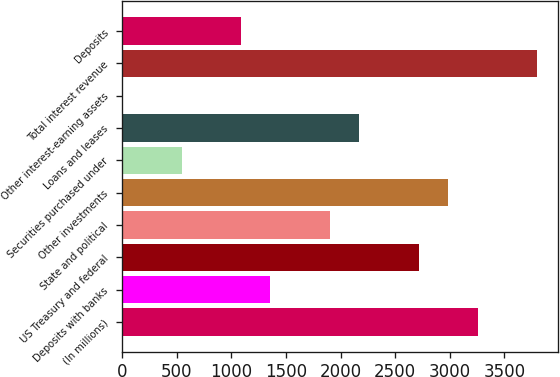Convert chart to OTSL. <chart><loc_0><loc_0><loc_500><loc_500><bar_chart><fcel>(In millions)<fcel>Deposits with banks<fcel>US Treasury and federal<fcel>State and political<fcel>Other investments<fcel>Securities purchased under<fcel>Loans and leases<fcel>Other interest-earning assets<fcel>Total interest revenue<fcel>Deposits<nl><fcel>3256<fcel>1359<fcel>2714<fcel>1901<fcel>2985<fcel>546<fcel>2172<fcel>4<fcel>3798<fcel>1088<nl></chart> 